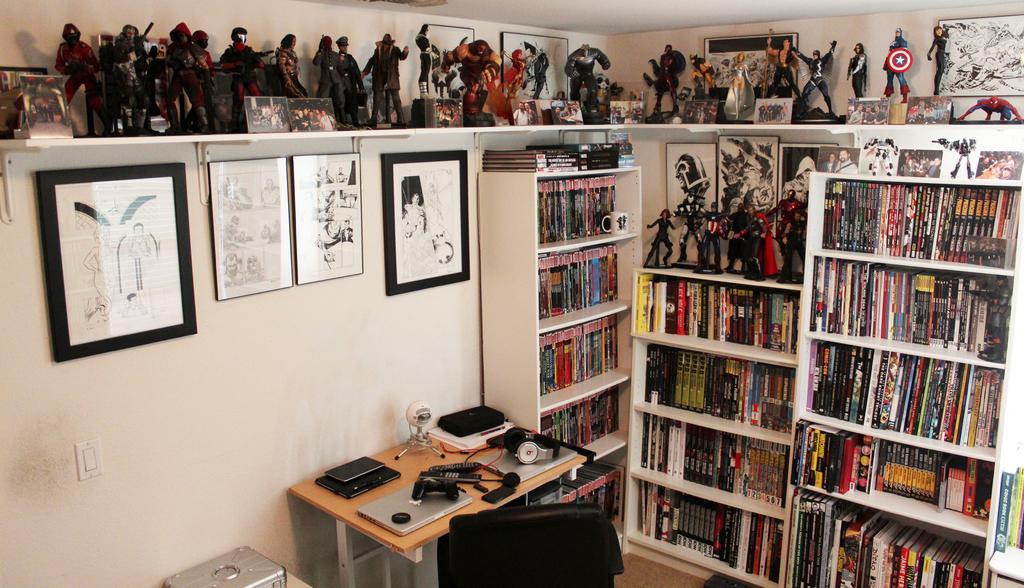How would you summarize this image in a sentence or two? This room consists of bookshelves, toys, photo frames on the wall, table and chair. On the table there are laptop, headphones, book, camera and there are books in bookshelves. 